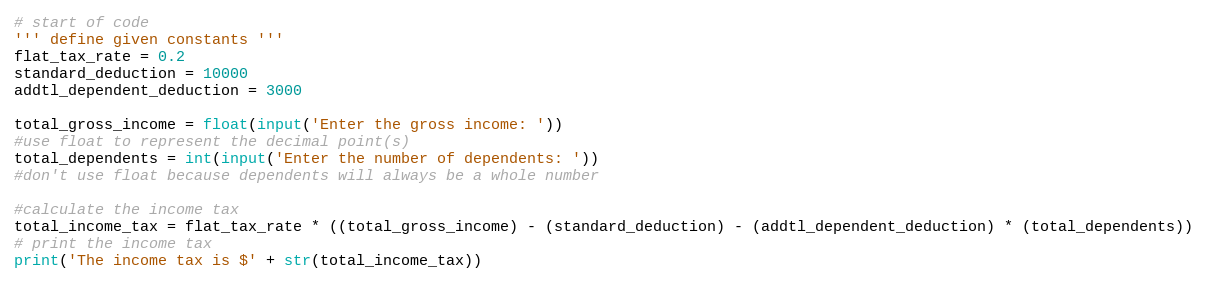Convert code to text. <code><loc_0><loc_0><loc_500><loc_500><_Python_># start of code 
''' define given constants '''
flat_tax_rate = 0.2
standard_deduction = 10000
addtl_dependent_deduction = 3000

total_gross_income = float(input('Enter the gross income: '))
#use float to represent the decimal point(s)
total_dependents = int(input('Enter the number of dependents: '))
#don't use float because dependents will always be a whole number

#calculate the income tax
total_income_tax = flat_tax_rate * ((total_gross_income) - (standard_deduction) - (addtl_dependent_deduction) * (total_dependents))
# print the income tax 
print('The income tax is $' + str(total_income_tax))</code> 